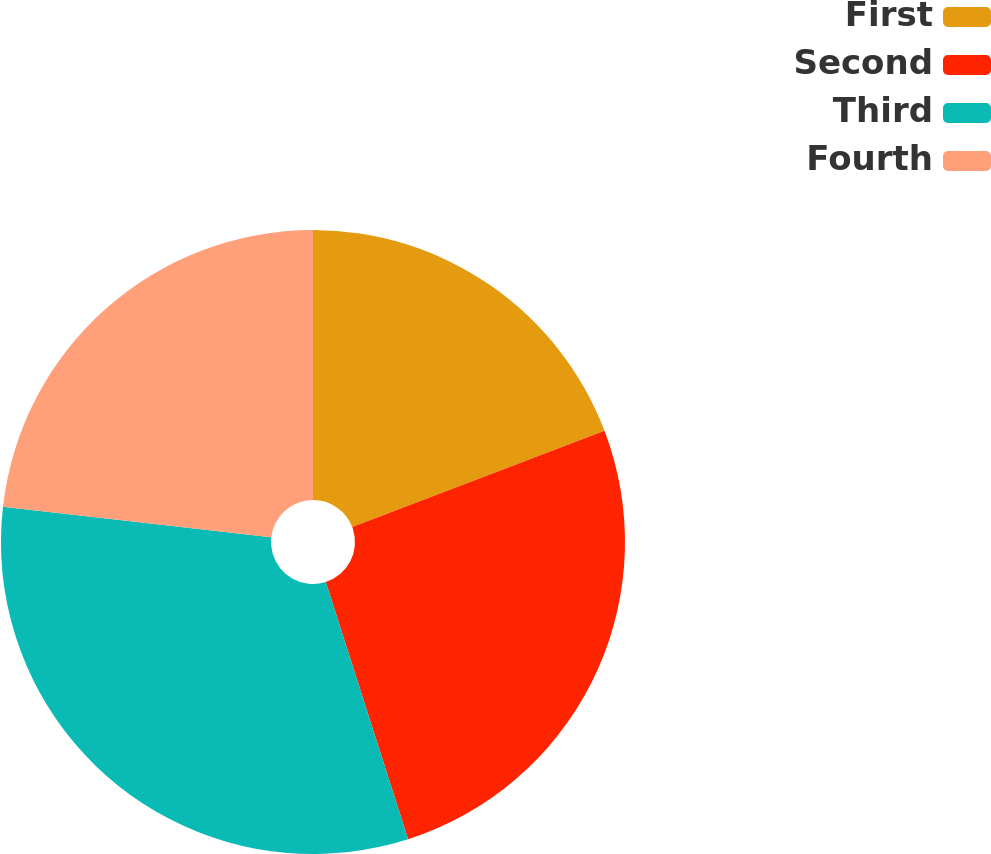Convert chart. <chart><loc_0><loc_0><loc_500><loc_500><pie_chart><fcel>First<fcel>Second<fcel>Third<fcel>Fourth<nl><fcel>19.2%<fcel>25.87%<fcel>31.73%<fcel>23.2%<nl></chart> 